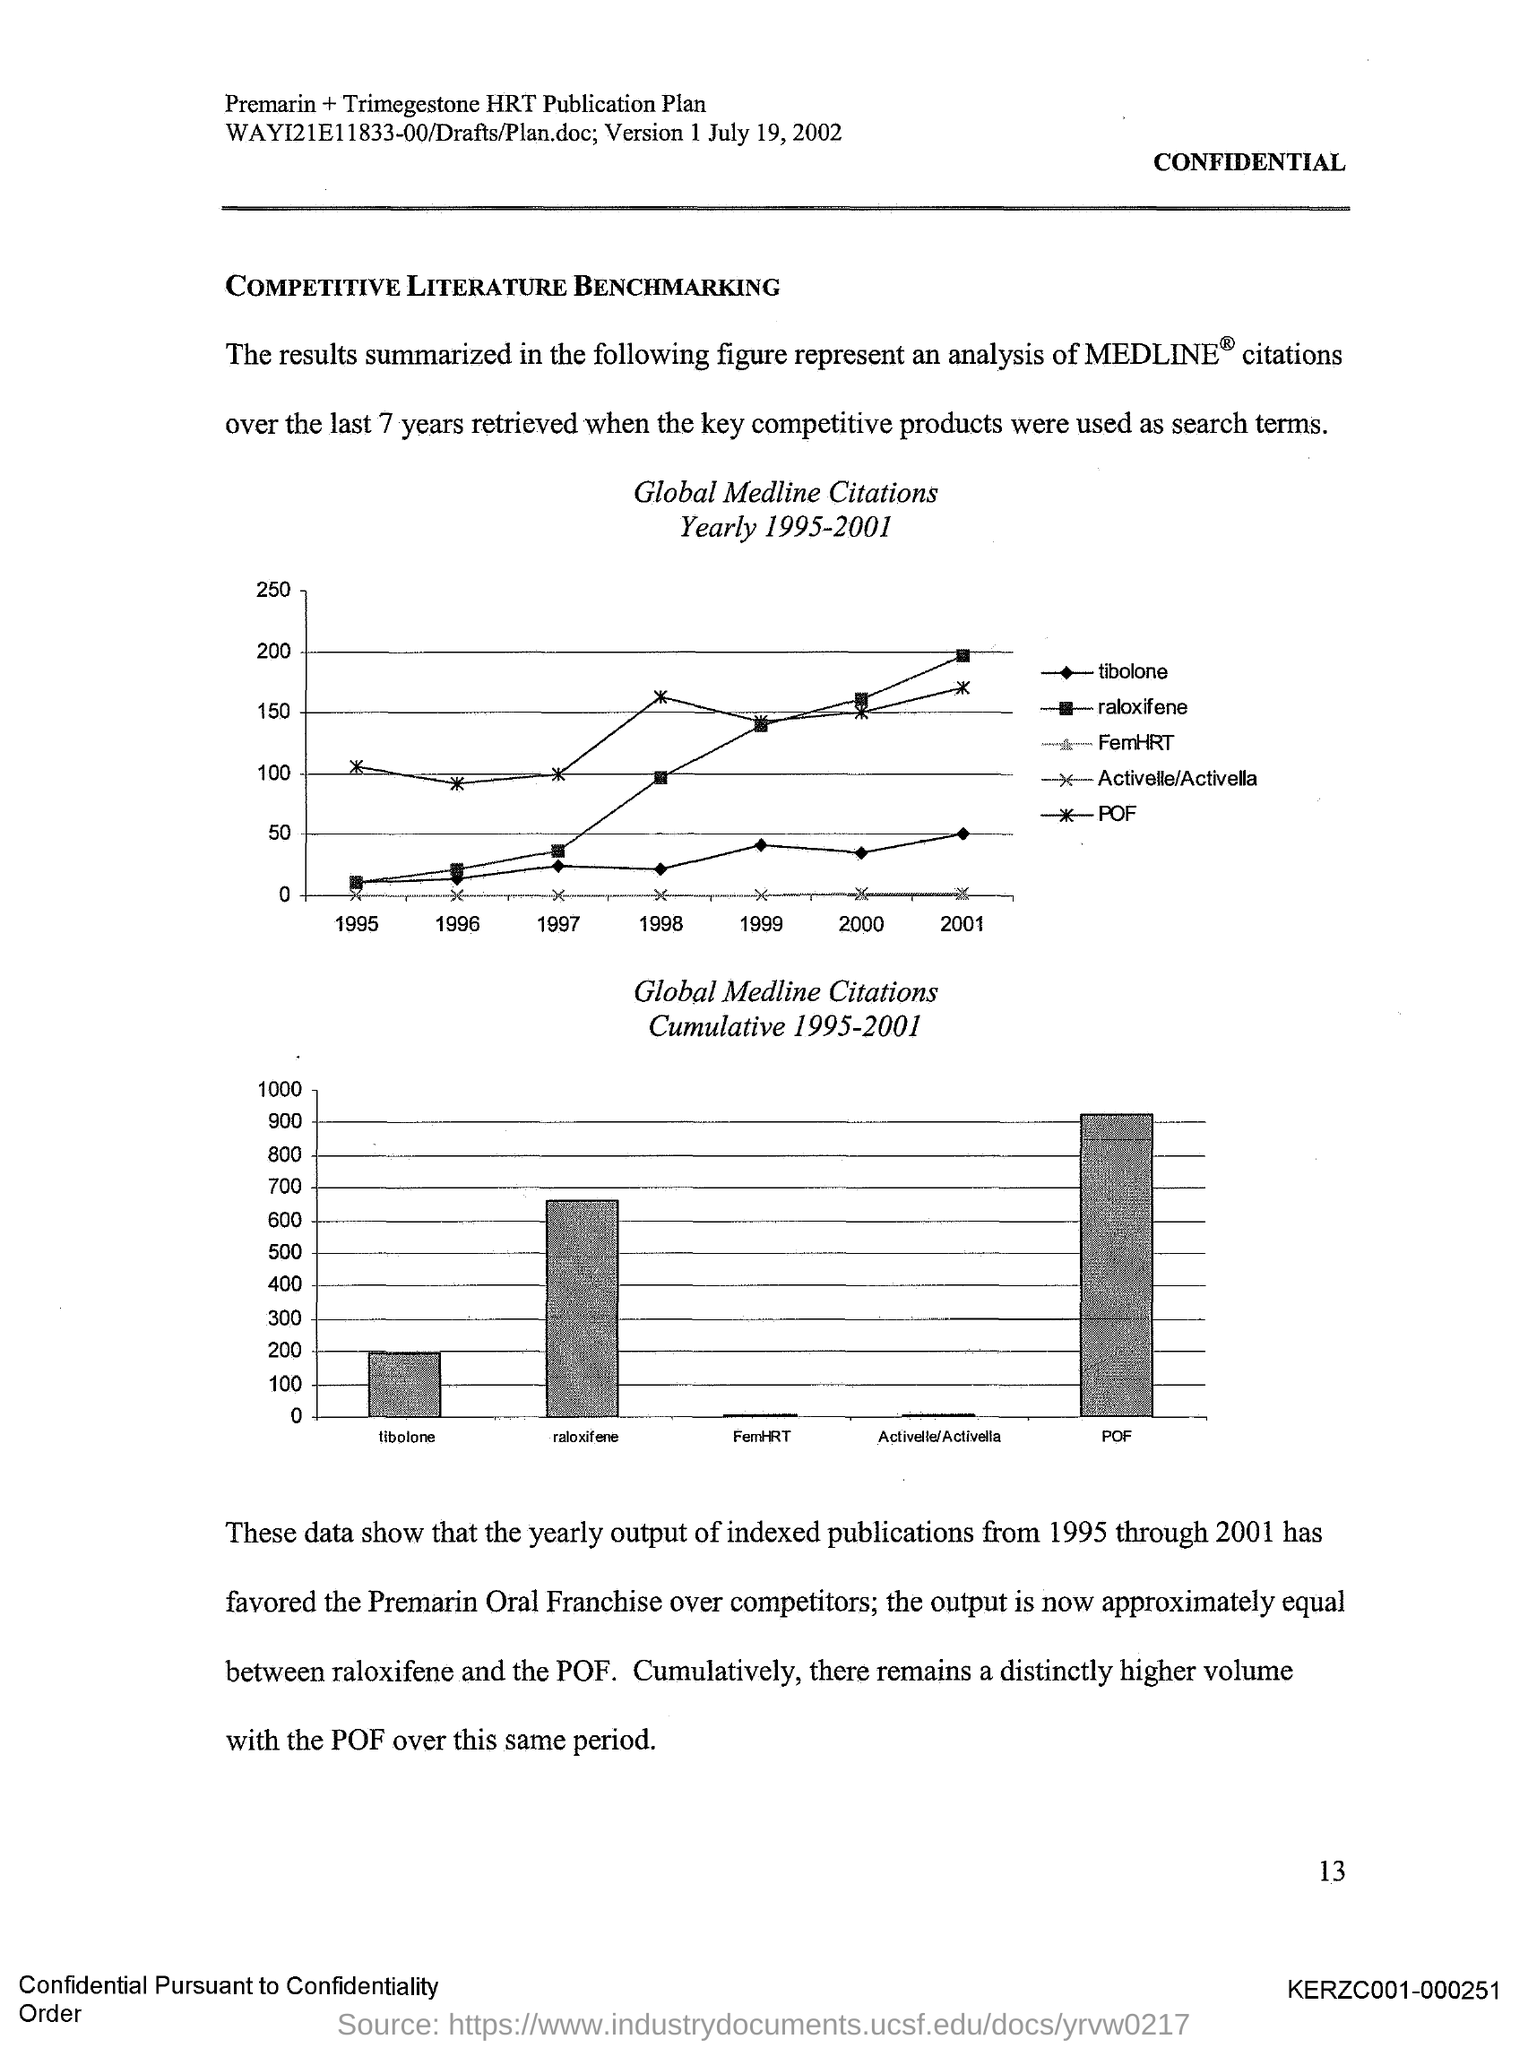Mention a couple of crucial points in this snapshot. The results summarized in the figure represent an analysis of MEDLINE citations. 